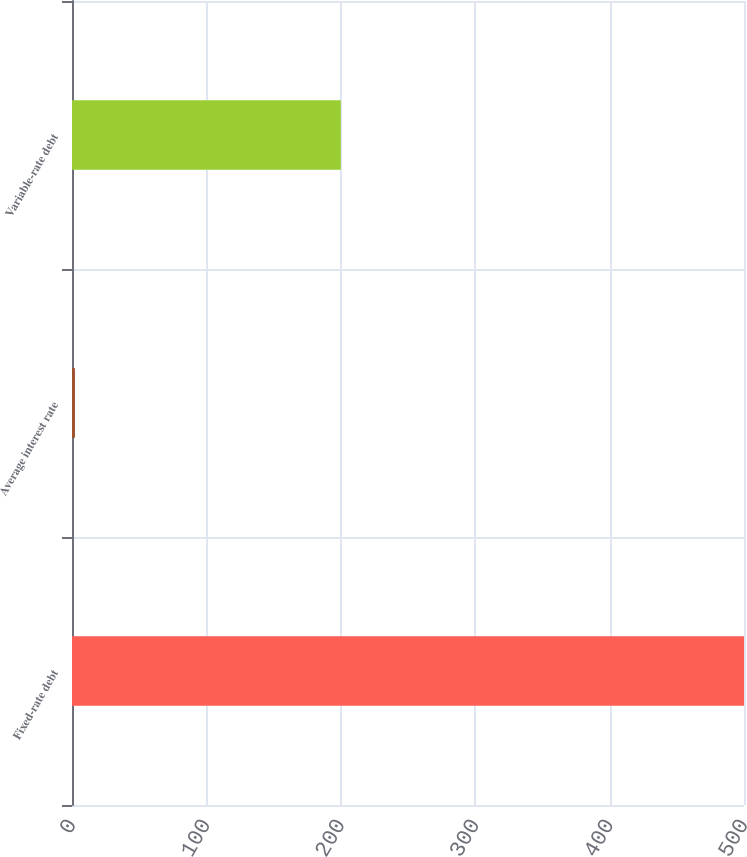Convert chart to OTSL. <chart><loc_0><loc_0><loc_500><loc_500><bar_chart><fcel>Fixed-rate debt<fcel>Average interest rate<fcel>Variable-rate debt<nl><fcel>500<fcel>2.2<fcel>200<nl></chart> 